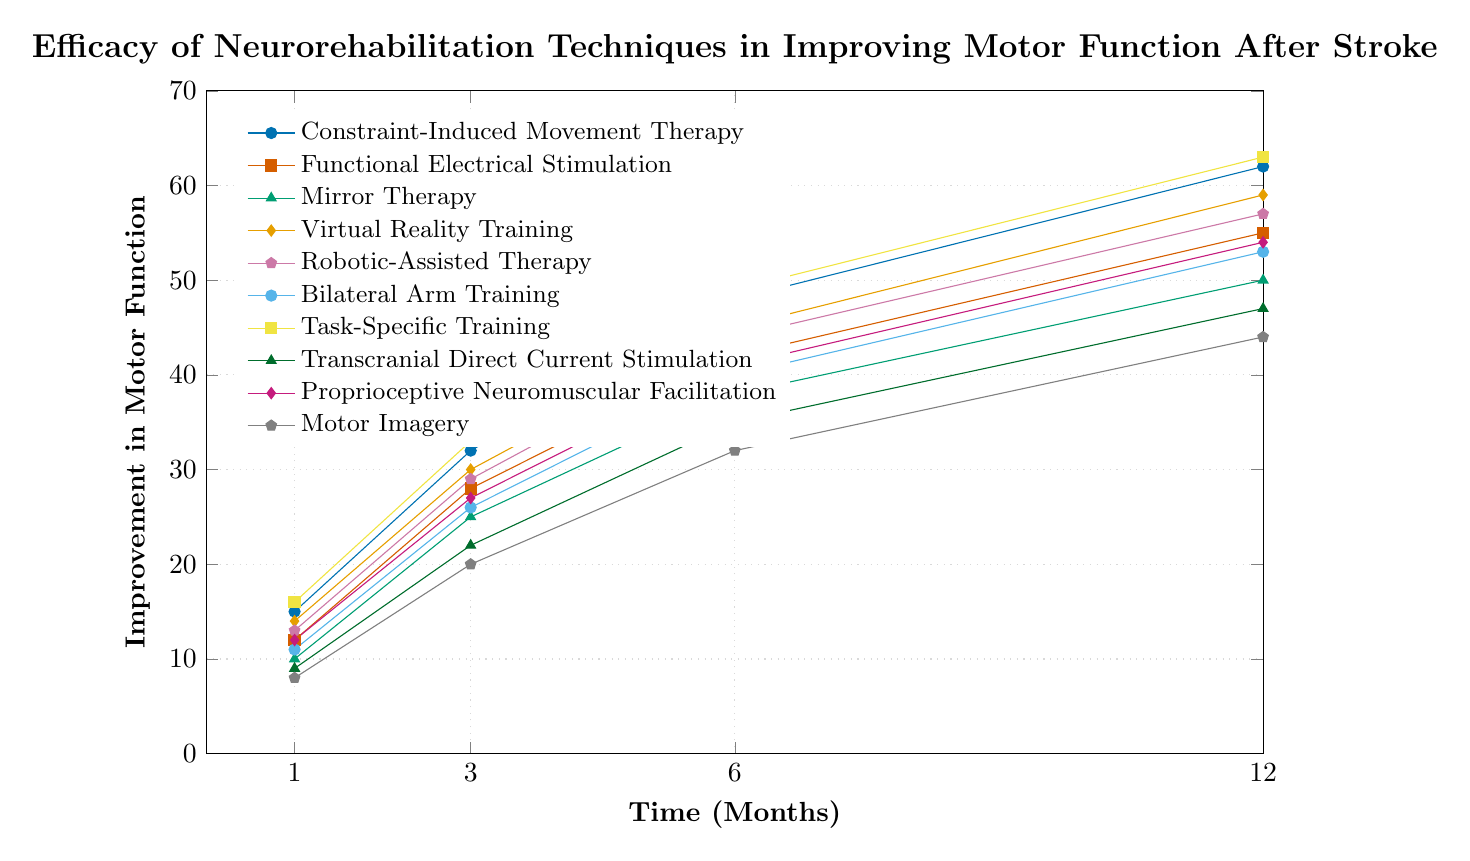What is the overall trend in improvement for all techniques over the 12-month period? Start at the 1-month marks and trace each technique's line to the 12-month marks. All lines show an increasing trend, indicating improvement in motor function over time.
Answer: Increasing Which technique has the highest improvement at 12 months? By visually inspecting the heights of the lines at 12 months, Task-Specific Training has the highest improvement, reaching a value of 63.
Answer: Task-Specific Training What is the average improvement for Virtual Reality Training across all time points? Sum the improvements for Virtual Reality Training at 1, 3, 6, and 12 months (14+30+45+59) which equals 148. Divide this by 4 (number of time points) to get an average of 37.
Answer: 37 Comparing the improvements at 6 months, which technique shows higher efficacy: Mirror Therapy or Proprioceptive Neuromuscular Facilitation? Locate the 6-month marks for both techniques. Mirror Therapy shows an improvement of 38, whereas Proprioceptive Neuromuscular Facilitation shows an improvement of 41.
Answer: Proprioceptive Neuromuscular Facilitation At which time point do most techniques surpass an improvement of 30? Trace each line and find the month where most of them cross the 30 mark. Most lines cross this threshold by the 6-month mark.
Answer: 6 months Which two techniques show the closest improvement at the 3-month mark? Observe the data points at the 3-month mark for all techniques. Functional Electrical Stimulation and Robotic-Assisted Therapy both show improvements of 28 and 29, respectively.
Answer: Functional Electrical Stimulation and Robotic-Assisted Therapy What is the approximate difference in improvement between Constraint-Induced Movement Therapy and Motor Imagery at 3 months? Look at the 3-month marks for both techniques. Constraint-Induced Movement Therapy shows an improvement of 32, and Motor Imagery shows 20. Subtracting these gives 32-20=12.
Answer: 12 Which technique exhibits the least improvement at the 1-month mark? Identify and compare the 1-month marks for each technique. Motor Imagery has the smallest value, which is 8.
Answer: Motor Imagery Do Constraint-Induced Movement Therapy and Task-Specific Training maintain their relative positions from 1 month to 12 months? Compare the relative heights of both lines at 1 month and 12 months. Constraint-Induced Movement Therapy starts below Task-Specific Training and remains below at 12 months.
Answer: Yes How does the improvement trajectory of Transcranial Direct Current Stimulation compare with Robotic-Assisted Therapy over the entire period? Compare the slopes of the lines for these two techniques. Transcranial Direct Current Stimulation starts lower and consistently stays lower than Robotic-Assisted Therapy through all time points.
Answer: Lower 